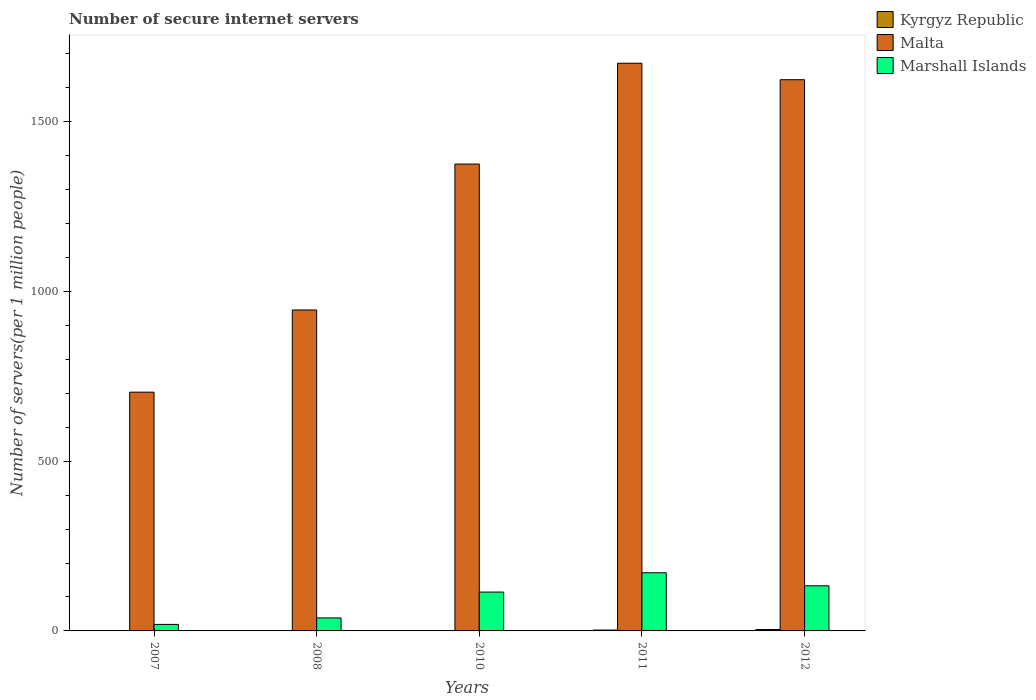Are the number of bars per tick equal to the number of legend labels?
Offer a very short reply. Yes. Are the number of bars on each tick of the X-axis equal?
Your response must be concise. Yes. How many bars are there on the 2nd tick from the left?
Make the answer very short. 3. What is the label of the 1st group of bars from the left?
Your answer should be very brief. 2007. In how many cases, is the number of bars for a given year not equal to the number of legend labels?
Your answer should be very brief. 0. What is the number of secure internet servers in Marshall Islands in 2008?
Keep it short and to the point. 38.3. Across all years, what is the maximum number of secure internet servers in Marshall Islands?
Your response must be concise. 171.29. Across all years, what is the minimum number of secure internet servers in Kyrgyz Republic?
Your answer should be compact. 0.56. In which year was the number of secure internet servers in Kyrgyz Republic minimum?
Your response must be concise. 2008. What is the total number of secure internet servers in Marshall Islands in the graph?
Ensure brevity in your answer.  476.14. What is the difference between the number of secure internet servers in Marshall Islands in 2008 and that in 2012?
Provide a short and direct response. -94.62. What is the difference between the number of secure internet servers in Marshall Islands in 2011 and the number of secure internet servers in Malta in 2012?
Offer a very short reply. -1452.24. What is the average number of secure internet servers in Malta per year?
Provide a short and direct response. 1263.83. In the year 2011, what is the difference between the number of secure internet servers in Malta and number of secure internet servers in Marshall Islands?
Provide a short and direct response. 1500.7. In how many years, is the number of secure internet servers in Marshall Islands greater than 800?
Keep it short and to the point. 0. What is the ratio of the number of secure internet servers in Malta in 2008 to that in 2012?
Your answer should be very brief. 0.58. What is the difference between the highest and the second highest number of secure internet servers in Kyrgyz Republic?
Offer a terse response. 1.56. What is the difference between the highest and the lowest number of secure internet servers in Malta?
Ensure brevity in your answer.  968.82. What does the 2nd bar from the left in 2010 represents?
Keep it short and to the point. Malta. What does the 2nd bar from the right in 2008 represents?
Your answer should be compact. Malta. Is it the case that in every year, the sum of the number of secure internet servers in Malta and number of secure internet servers in Marshall Islands is greater than the number of secure internet servers in Kyrgyz Republic?
Ensure brevity in your answer.  Yes. How many bars are there?
Offer a very short reply. 15. Are all the bars in the graph horizontal?
Offer a very short reply. No. How many years are there in the graph?
Offer a very short reply. 5. Are the values on the major ticks of Y-axis written in scientific E-notation?
Provide a short and direct response. No. Does the graph contain any zero values?
Give a very brief answer. No. Does the graph contain grids?
Offer a very short reply. No. What is the title of the graph?
Ensure brevity in your answer.  Number of secure internet servers. Does "Tanzania" appear as one of the legend labels in the graph?
Your response must be concise. No. What is the label or title of the X-axis?
Your answer should be compact. Years. What is the label or title of the Y-axis?
Your answer should be compact. Number of servers(per 1 million people). What is the Number of servers(per 1 million people) in Kyrgyz Republic in 2007?
Make the answer very short. 0.95. What is the Number of servers(per 1 million people) in Malta in 2007?
Give a very brief answer. 703.18. What is the Number of servers(per 1 million people) in Marshall Islands in 2007?
Ensure brevity in your answer.  19.18. What is the Number of servers(per 1 million people) of Kyrgyz Republic in 2008?
Your answer should be very brief. 0.56. What is the Number of servers(per 1 million people) in Malta in 2008?
Keep it short and to the point. 945.33. What is the Number of servers(per 1 million people) in Marshall Islands in 2008?
Make the answer very short. 38.3. What is the Number of servers(per 1 million people) of Kyrgyz Republic in 2010?
Your answer should be very brief. 1.1. What is the Number of servers(per 1 million people) in Malta in 2010?
Ensure brevity in your answer.  1375.12. What is the Number of servers(per 1 million people) in Marshall Islands in 2010?
Your response must be concise. 114.44. What is the Number of servers(per 1 million people) in Kyrgyz Republic in 2011?
Provide a succinct answer. 2.54. What is the Number of servers(per 1 million people) in Malta in 2011?
Ensure brevity in your answer.  1672. What is the Number of servers(per 1 million people) of Marshall Islands in 2011?
Offer a terse response. 171.29. What is the Number of servers(per 1 million people) of Kyrgyz Republic in 2012?
Offer a terse response. 4.1. What is the Number of servers(per 1 million people) in Malta in 2012?
Offer a terse response. 1623.54. What is the Number of servers(per 1 million people) in Marshall Islands in 2012?
Your answer should be very brief. 132.92. Across all years, what is the maximum Number of servers(per 1 million people) in Kyrgyz Republic?
Keep it short and to the point. 4.1. Across all years, what is the maximum Number of servers(per 1 million people) of Malta?
Make the answer very short. 1672. Across all years, what is the maximum Number of servers(per 1 million people) of Marshall Islands?
Your response must be concise. 171.29. Across all years, what is the minimum Number of servers(per 1 million people) in Kyrgyz Republic?
Provide a succinct answer. 0.56. Across all years, what is the minimum Number of servers(per 1 million people) in Malta?
Provide a succinct answer. 703.18. Across all years, what is the minimum Number of servers(per 1 million people) of Marshall Islands?
Provide a short and direct response. 19.18. What is the total Number of servers(per 1 million people) of Kyrgyz Republic in the graph?
Offer a terse response. 9.26. What is the total Number of servers(per 1 million people) in Malta in the graph?
Provide a succinct answer. 6319.17. What is the total Number of servers(per 1 million people) of Marshall Islands in the graph?
Ensure brevity in your answer.  476.14. What is the difference between the Number of servers(per 1 million people) in Kyrgyz Republic in 2007 and that in 2008?
Offer a terse response. 0.39. What is the difference between the Number of servers(per 1 million people) of Malta in 2007 and that in 2008?
Provide a succinct answer. -242.15. What is the difference between the Number of servers(per 1 million people) of Marshall Islands in 2007 and that in 2008?
Provide a succinct answer. -19.12. What is the difference between the Number of servers(per 1 million people) in Kyrgyz Republic in 2007 and that in 2010?
Your answer should be compact. -0.15. What is the difference between the Number of servers(per 1 million people) in Malta in 2007 and that in 2010?
Provide a short and direct response. -671.94. What is the difference between the Number of servers(per 1 million people) of Marshall Islands in 2007 and that in 2010?
Offer a very short reply. -95.26. What is the difference between the Number of servers(per 1 million people) in Kyrgyz Republic in 2007 and that in 2011?
Your answer should be compact. -1.59. What is the difference between the Number of servers(per 1 million people) in Malta in 2007 and that in 2011?
Give a very brief answer. -968.82. What is the difference between the Number of servers(per 1 million people) in Marshall Islands in 2007 and that in 2011?
Give a very brief answer. -152.11. What is the difference between the Number of servers(per 1 million people) of Kyrgyz Republic in 2007 and that in 2012?
Provide a short and direct response. -3.15. What is the difference between the Number of servers(per 1 million people) in Malta in 2007 and that in 2012?
Provide a succinct answer. -920.36. What is the difference between the Number of servers(per 1 million people) of Marshall Islands in 2007 and that in 2012?
Provide a succinct answer. -113.74. What is the difference between the Number of servers(per 1 million people) in Kyrgyz Republic in 2008 and that in 2010?
Give a very brief answer. -0.54. What is the difference between the Number of servers(per 1 million people) in Malta in 2008 and that in 2010?
Ensure brevity in your answer.  -429.79. What is the difference between the Number of servers(per 1 million people) of Marshall Islands in 2008 and that in 2010?
Provide a succinct answer. -76.14. What is the difference between the Number of servers(per 1 million people) of Kyrgyz Republic in 2008 and that in 2011?
Your response must be concise. -1.97. What is the difference between the Number of servers(per 1 million people) in Malta in 2008 and that in 2011?
Offer a very short reply. -726.67. What is the difference between the Number of servers(per 1 million people) of Marshall Islands in 2008 and that in 2011?
Provide a short and direct response. -133. What is the difference between the Number of servers(per 1 million people) in Kyrgyz Republic in 2008 and that in 2012?
Provide a succinct answer. -3.54. What is the difference between the Number of servers(per 1 million people) of Malta in 2008 and that in 2012?
Offer a terse response. -678.2. What is the difference between the Number of servers(per 1 million people) in Marshall Islands in 2008 and that in 2012?
Your answer should be compact. -94.62. What is the difference between the Number of servers(per 1 million people) of Kyrgyz Republic in 2010 and that in 2011?
Offer a terse response. -1.44. What is the difference between the Number of servers(per 1 million people) in Malta in 2010 and that in 2011?
Your answer should be compact. -296.88. What is the difference between the Number of servers(per 1 million people) in Marshall Islands in 2010 and that in 2011?
Your answer should be very brief. -56.85. What is the difference between the Number of servers(per 1 million people) of Kyrgyz Republic in 2010 and that in 2012?
Give a very brief answer. -3. What is the difference between the Number of servers(per 1 million people) in Malta in 2010 and that in 2012?
Offer a very short reply. -248.41. What is the difference between the Number of servers(per 1 million people) in Marshall Islands in 2010 and that in 2012?
Keep it short and to the point. -18.48. What is the difference between the Number of servers(per 1 million people) of Kyrgyz Republic in 2011 and that in 2012?
Your answer should be very brief. -1.56. What is the difference between the Number of servers(per 1 million people) of Malta in 2011 and that in 2012?
Offer a very short reply. 48.46. What is the difference between the Number of servers(per 1 million people) of Marshall Islands in 2011 and that in 2012?
Provide a succinct answer. 38.37. What is the difference between the Number of servers(per 1 million people) of Kyrgyz Republic in 2007 and the Number of servers(per 1 million people) of Malta in 2008?
Offer a terse response. -944.39. What is the difference between the Number of servers(per 1 million people) of Kyrgyz Republic in 2007 and the Number of servers(per 1 million people) of Marshall Islands in 2008?
Make the answer very short. -37.35. What is the difference between the Number of servers(per 1 million people) of Malta in 2007 and the Number of servers(per 1 million people) of Marshall Islands in 2008?
Give a very brief answer. 664.88. What is the difference between the Number of servers(per 1 million people) of Kyrgyz Republic in 2007 and the Number of servers(per 1 million people) of Malta in 2010?
Give a very brief answer. -1374.18. What is the difference between the Number of servers(per 1 million people) of Kyrgyz Republic in 2007 and the Number of servers(per 1 million people) of Marshall Islands in 2010?
Provide a short and direct response. -113.49. What is the difference between the Number of servers(per 1 million people) in Malta in 2007 and the Number of servers(per 1 million people) in Marshall Islands in 2010?
Offer a very short reply. 588.74. What is the difference between the Number of servers(per 1 million people) of Kyrgyz Republic in 2007 and the Number of servers(per 1 million people) of Malta in 2011?
Provide a short and direct response. -1671.05. What is the difference between the Number of servers(per 1 million people) of Kyrgyz Republic in 2007 and the Number of servers(per 1 million people) of Marshall Islands in 2011?
Your answer should be very brief. -170.35. What is the difference between the Number of servers(per 1 million people) of Malta in 2007 and the Number of servers(per 1 million people) of Marshall Islands in 2011?
Keep it short and to the point. 531.88. What is the difference between the Number of servers(per 1 million people) in Kyrgyz Republic in 2007 and the Number of servers(per 1 million people) in Malta in 2012?
Your answer should be compact. -1622.59. What is the difference between the Number of servers(per 1 million people) in Kyrgyz Republic in 2007 and the Number of servers(per 1 million people) in Marshall Islands in 2012?
Your answer should be very brief. -131.97. What is the difference between the Number of servers(per 1 million people) of Malta in 2007 and the Number of servers(per 1 million people) of Marshall Islands in 2012?
Offer a very short reply. 570.26. What is the difference between the Number of servers(per 1 million people) of Kyrgyz Republic in 2008 and the Number of servers(per 1 million people) of Malta in 2010?
Your answer should be very brief. -1374.56. What is the difference between the Number of servers(per 1 million people) in Kyrgyz Republic in 2008 and the Number of servers(per 1 million people) in Marshall Islands in 2010?
Make the answer very short. -113.88. What is the difference between the Number of servers(per 1 million people) in Malta in 2008 and the Number of servers(per 1 million people) in Marshall Islands in 2010?
Offer a very short reply. 830.89. What is the difference between the Number of servers(per 1 million people) in Kyrgyz Republic in 2008 and the Number of servers(per 1 million people) in Malta in 2011?
Your answer should be compact. -1671.44. What is the difference between the Number of servers(per 1 million people) in Kyrgyz Republic in 2008 and the Number of servers(per 1 million people) in Marshall Islands in 2011?
Keep it short and to the point. -170.73. What is the difference between the Number of servers(per 1 million people) in Malta in 2008 and the Number of servers(per 1 million people) in Marshall Islands in 2011?
Provide a short and direct response. 774.04. What is the difference between the Number of servers(per 1 million people) of Kyrgyz Republic in 2008 and the Number of servers(per 1 million people) of Malta in 2012?
Offer a terse response. -1622.97. What is the difference between the Number of servers(per 1 million people) of Kyrgyz Republic in 2008 and the Number of servers(per 1 million people) of Marshall Islands in 2012?
Provide a short and direct response. -132.36. What is the difference between the Number of servers(per 1 million people) of Malta in 2008 and the Number of servers(per 1 million people) of Marshall Islands in 2012?
Make the answer very short. 812.41. What is the difference between the Number of servers(per 1 million people) of Kyrgyz Republic in 2010 and the Number of servers(per 1 million people) of Malta in 2011?
Give a very brief answer. -1670.9. What is the difference between the Number of servers(per 1 million people) in Kyrgyz Republic in 2010 and the Number of servers(per 1 million people) in Marshall Islands in 2011?
Provide a succinct answer. -170.19. What is the difference between the Number of servers(per 1 million people) in Malta in 2010 and the Number of servers(per 1 million people) in Marshall Islands in 2011?
Provide a succinct answer. 1203.83. What is the difference between the Number of servers(per 1 million people) in Kyrgyz Republic in 2010 and the Number of servers(per 1 million people) in Malta in 2012?
Offer a very short reply. -1622.43. What is the difference between the Number of servers(per 1 million people) of Kyrgyz Republic in 2010 and the Number of servers(per 1 million people) of Marshall Islands in 2012?
Your response must be concise. -131.82. What is the difference between the Number of servers(per 1 million people) of Malta in 2010 and the Number of servers(per 1 million people) of Marshall Islands in 2012?
Your answer should be compact. 1242.2. What is the difference between the Number of servers(per 1 million people) of Kyrgyz Republic in 2011 and the Number of servers(per 1 million people) of Malta in 2012?
Offer a terse response. -1621. What is the difference between the Number of servers(per 1 million people) of Kyrgyz Republic in 2011 and the Number of servers(per 1 million people) of Marshall Islands in 2012?
Ensure brevity in your answer.  -130.38. What is the difference between the Number of servers(per 1 million people) of Malta in 2011 and the Number of servers(per 1 million people) of Marshall Islands in 2012?
Your response must be concise. 1539.08. What is the average Number of servers(per 1 million people) in Kyrgyz Republic per year?
Your answer should be very brief. 1.85. What is the average Number of servers(per 1 million people) in Malta per year?
Ensure brevity in your answer.  1263.83. What is the average Number of servers(per 1 million people) in Marshall Islands per year?
Make the answer very short. 95.23. In the year 2007, what is the difference between the Number of servers(per 1 million people) of Kyrgyz Republic and Number of servers(per 1 million people) of Malta?
Provide a succinct answer. -702.23. In the year 2007, what is the difference between the Number of servers(per 1 million people) of Kyrgyz Republic and Number of servers(per 1 million people) of Marshall Islands?
Your response must be concise. -18.23. In the year 2007, what is the difference between the Number of servers(per 1 million people) of Malta and Number of servers(per 1 million people) of Marshall Islands?
Offer a very short reply. 684. In the year 2008, what is the difference between the Number of servers(per 1 million people) in Kyrgyz Republic and Number of servers(per 1 million people) in Malta?
Provide a short and direct response. -944.77. In the year 2008, what is the difference between the Number of servers(per 1 million people) in Kyrgyz Republic and Number of servers(per 1 million people) in Marshall Islands?
Provide a succinct answer. -37.73. In the year 2008, what is the difference between the Number of servers(per 1 million people) of Malta and Number of servers(per 1 million people) of Marshall Islands?
Give a very brief answer. 907.04. In the year 2010, what is the difference between the Number of servers(per 1 million people) in Kyrgyz Republic and Number of servers(per 1 million people) in Malta?
Keep it short and to the point. -1374.02. In the year 2010, what is the difference between the Number of servers(per 1 million people) of Kyrgyz Republic and Number of servers(per 1 million people) of Marshall Islands?
Offer a very short reply. -113.34. In the year 2010, what is the difference between the Number of servers(per 1 million people) in Malta and Number of servers(per 1 million people) in Marshall Islands?
Ensure brevity in your answer.  1260.68. In the year 2011, what is the difference between the Number of servers(per 1 million people) in Kyrgyz Republic and Number of servers(per 1 million people) in Malta?
Your answer should be very brief. -1669.46. In the year 2011, what is the difference between the Number of servers(per 1 million people) of Kyrgyz Republic and Number of servers(per 1 million people) of Marshall Islands?
Provide a short and direct response. -168.76. In the year 2011, what is the difference between the Number of servers(per 1 million people) of Malta and Number of servers(per 1 million people) of Marshall Islands?
Provide a short and direct response. 1500.7. In the year 2012, what is the difference between the Number of servers(per 1 million people) of Kyrgyz Republic and Number of servers(per 1 million people) of Malta?
Your answer should be compact. -1619.43. In the year 2012, what is the difference between the Number of servers(per 1 million people) in Kyrgyz Republic and Number of servers(per 1 million people) in Marshall Islands?
Offer a terse response. -128.82. In the year 2012, what is the difference between the Number of servers(per 1 million people) of Malta and Number of servers(per 1 million people) of Marshall Islands?
Your answer should be compact. 1490.61. What is the ratio of the Number of servers(per 1 million people) of Kyrgyz Republic in 2007 to that in 2008?
Your answer should be very brief. 1.68. What is the ratio of the Number of servers(per 1 million people) of Malta in 2007 to that in 2008?
Your answer should be very brief. 0.74. What is the ratio of the Number of servers(per 1 million people) of Marshall Islands in 2007 to that in 2008?
Provide a short and direct response. 0.5. What is the ratio of the Number of servers(per 1 million people) of Kyrgyz Republic in 2007 to that in 2010?
Make the answer very short. 0.86. What is the ratio of the Number of servers(per 1 million people) of Malta in 2007 to that in 2010?
Provide a short and direct response. 0.51. What is the ratio of the Number of servers(per 1 million people) in Marshall Islands in 2007 to that in 2010?
Offer a terse response. 0.17. What is the ratio of the Number of servers(per 1 million people) of Kyrgyz Republic in 2007 to that in 2011?
Keep it short and to the point. 0.37. What is the ratio of the Number of servers(per 1 million people) in Malta in 2007 to that in 2011?
Offer a terse response. 0.42. What is the ratio of the Number of servers(per 1 million people) of Marshall Islands in 2007 to that in 2011?
Offer a very short reply. 0.11. What is the ratio of the Number of servers(per 1 million people) in Kyrgyz Republic in 2007 to that in 2012?
Make the answer very short. 0.23. What is the ratio of the Number of servers(per 1 million people) of Malta in 2007 to that in 2012?
Provide a succinct answer. 0.43. What is the ratio of the Number of servers(per 1 million people) in Marshall Islands in 2007 to that in 2012?
Provide a succinct answer. 0.14. What is the ratio of the Number of servers(per 1 million people) in Kyrgyz Republic in 2008 to that in 2010?
Your answer should be very brief. 0.51. What is the ratio of the Number of servers(per 1 million people) in Malta in 2008 to that in 2010?
Ensure brevity in your answer.  0.69. What is the ratio of the Number of servers(per 1 million people) in Marshall Islands in 2008 to that in 2010?
Make the answer very short. 0.33. What is the ratio of the Number of servers(per 1 million people) in Kyrgyz Republic in 2008 to that in 2011?
Provide a succinct answer. 0.22. What is the ratio of the Number of servers(per 1 million people) of Malta in 2008 to that in 2011?
Provide a short and direct response. 0.57. What is the ratio of the Number of servers(per 1 million people) in Marshall Islands in 2008 to that in 2011?
Make the answer very short. 0.22. What is the ratio of the Number of servers(per 1 million people) of Kyrgyz Republic in 2008 to that in 2012?
Ensure brevity in your answer.  0.14. What is the ratio of the Number of servers(per 1 million people) of Malta in 2008 to that in 2012?
Provide a short and direct response. 0.58. What is the ratio of the Number of servers(per 1 million people) of Marshall Islands in 2008 to that in 2012?
Provide a short and direct response. 0.29. What is the ratio of the Number of servers(per 1 million people) of Kyrgyz Republic in 2010 to that in 2011?
Your answer should be very brief. 0.43. What is the ratio of the Number of servers(per 1 million people) in Malta in 2010 to that in 2011?
Ensure brevity in your answer.  0.82. What is the ratio of the Number of servers(per 1 million people) of Marshall Islands in 2010 to that in 2011?
Your answer should be compact. 0.67. What is the ratio of the Number of servers(per 1 million people) of Kyrgyz Republic in 2010 to that in 2012?
Provide a succinct answer. 0.27. What is the ratio of the Number of servers(per 1 million people) in Malta in 2010 to that in 2012?
Provide a succinct answer. 0.85. What is the ratio of the Number of servers(per 1 million people) in Marshall Islands in 2010 to that in 2012?
Provide a short and direct response. 0.86. What is the ratio of the Number of servers(per 1 million people) of Kyrgyz Republic in 2011 to that in 2012?
Your answer should be very brief. 0.62. What is the ratio of the Number of servers(per 1 million people) of Malta in 2011 to that in 2012?
Provide a short and direct response. 1.03. What is the ratio of the Number of servers(per 1 million people) of Marshall Islands in 2011 to that in 2012?
Provide a succinct answer. 1.29. What is the difference between the highest and the second highest Number of servers(per 1 million people) of Kyrgyz Republic?
Give a very brief answer. 1.56. What is the difference between the highest and the second highest Number of servers(per 1 million people) in Malta?
Your answer should be very brief. 48.46. What is the difference between the highest and the second highest Number of servers(per 1 million people) in Marshall Islands?
Provide a short and direct response. 38.37. What is the difference between the highest and the lowest Number of servers(per 1 million people) in Kyrgyz Republic?
Ensure brevity in your answer.  3.54. What is the difference between the highest and the lowest Number of servers(per 1 million people) of Malta?
Offer a very short reply. 968.82. What is the difference between the highest and the lowest Number of servers(per 1 million people) of Marshall Islands?
Provide a short and direct response. 152.11. 